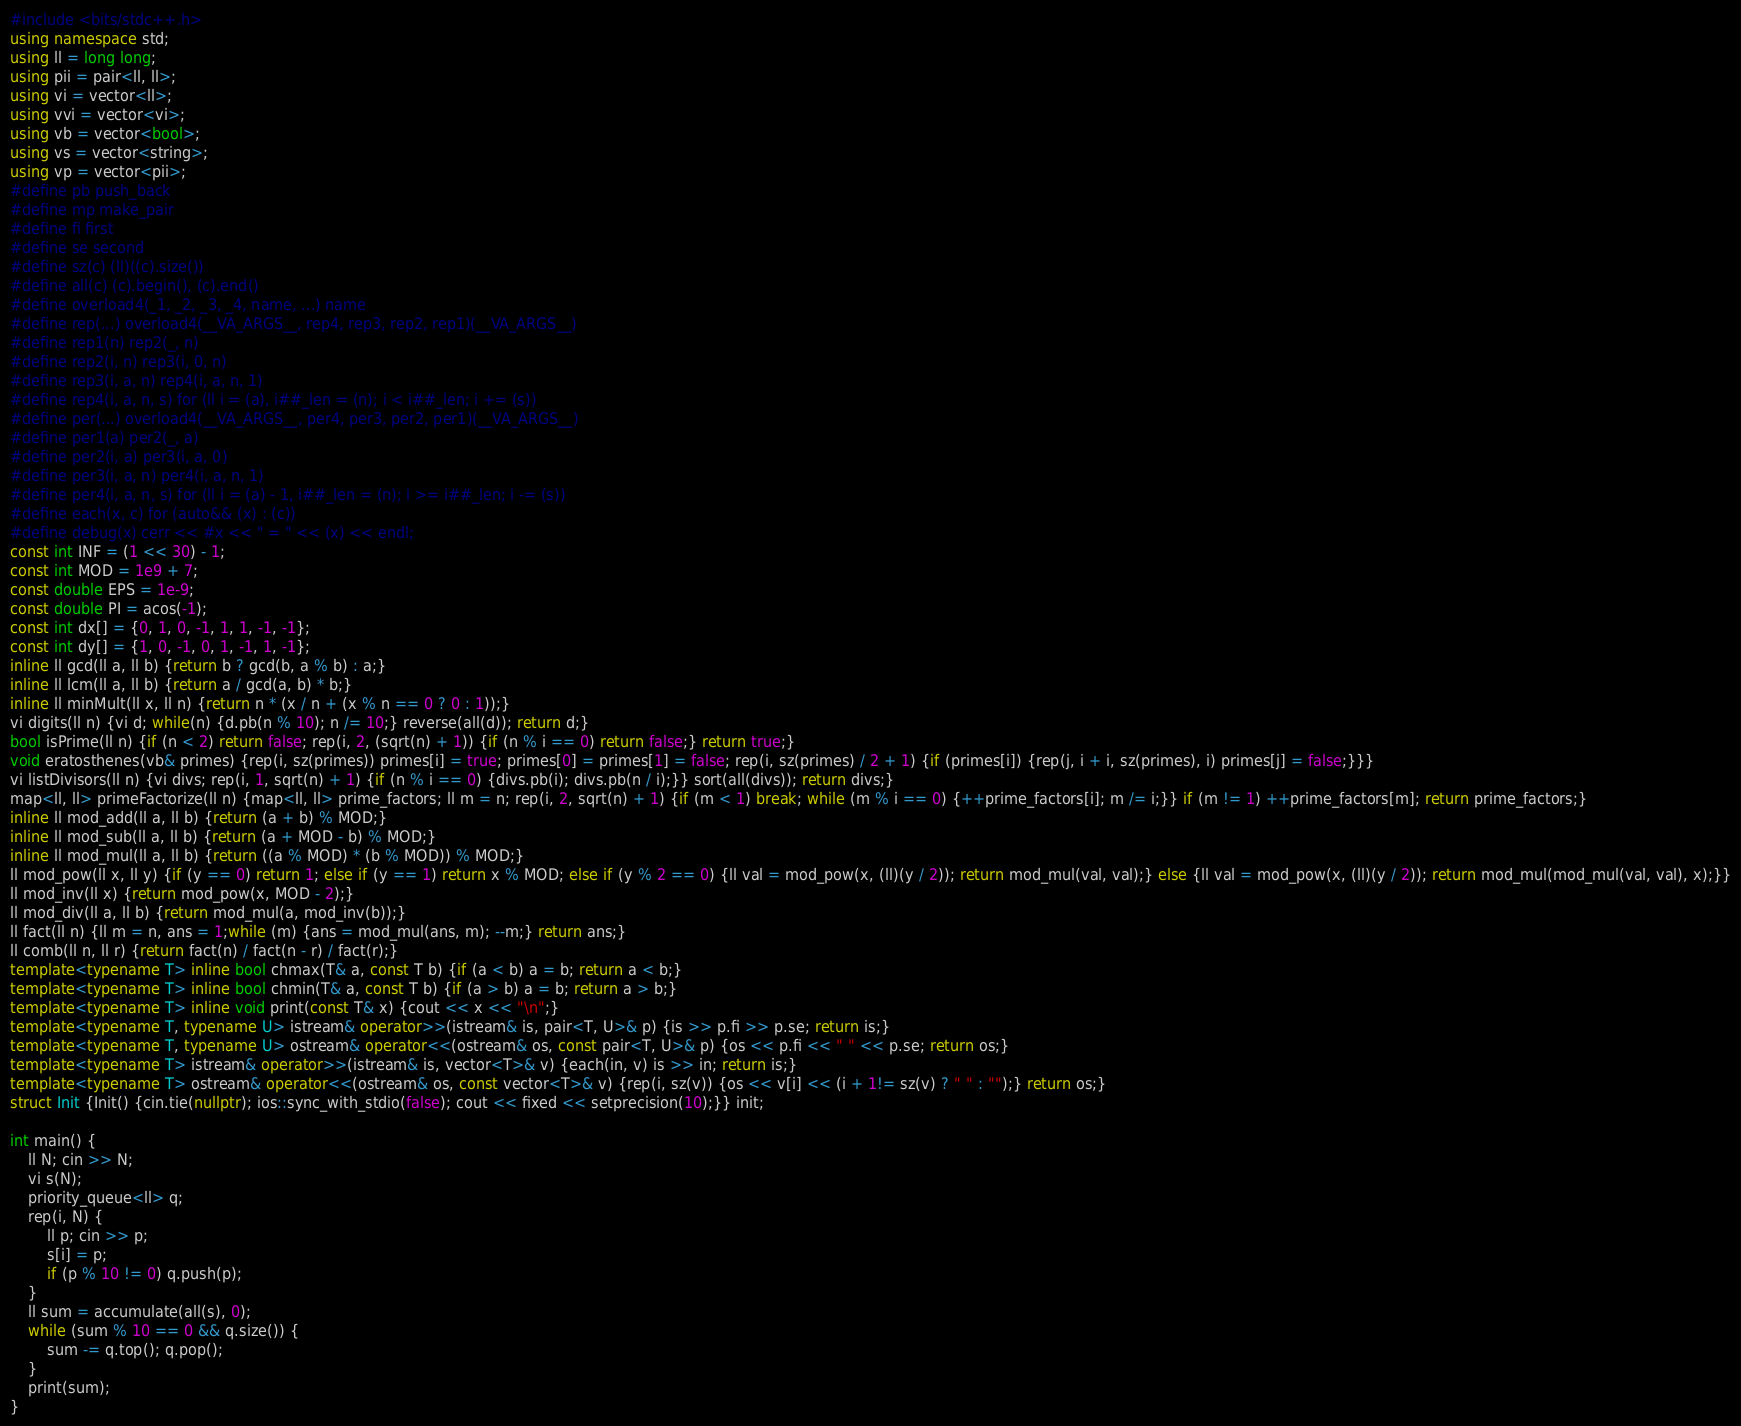<code> <loc_0><loc_0><loc_500><loc_500><_C++_>#include <bits/stdc++.h>
using namespace std;
using ll = long long;
using pii = pair<ll, ll>;
using vi = vector<ll>;
using vvi = vector<vi>;
using vb = vector<bool>;
using vs = vector<string>;
using vp = vector<pii>;
#define pb push_back
#define mp make_pair
#define fi first
#define se second
#define sz(c) (ll)((c).size())
#define all(c) (c).begin(), (c).end()
#define overload4(_1, _2, _3, _4, name, ...) name
#define rep(...) overload4(__VA_ARGS__, rep4, rep3, rep2, rep1)(__VA_ARGS__)
#define rep1(n) rep2(_, n)
#define rep2(i, n) rep3(i, 0, n)
#define rep3(i, a, n) rep4(i, a, n, 1)
#define rep4(i, a, n, s) for (ll i = (a), i##_len = (n); i < i##_len; i += (s))
#define per(...) overload4(__VA_ARGS__, per4, per3, per2, per1)(__VA_ARGS__)
#define per1(a) per2(_, a)
#define per2(i, a) per3(i, a, 0)
#define per3(i, a, n) per4(i, a, n, 1)
#define per4(i, a, n, s) for (ll i = (a) - 1, i##_len = (n); i >= i##_len; i -= (s))
#define each(x, c) for (auto&& (x) : (c))
#define debug(x) cerr << #x << " = " << (x) << endl;
const int INF = (1 << 30) - 1;
const int MOD = 1e9 + 7;
const double EPS = 1e-9;
const double PI = acos(-1);
const int dx[] = {0, 1, 0, -1, 1, 1, -1, -1};
const int dy[] = {1, 0, -1, 0, 1, -1, 1, -1};
inline ll gcd(ll a, ll b) {return b ? gcd(b, a % b) : a;}
inline ll lcm(ll a, ll b) {return a / gcd(a, b) * b;}
inline ll minMult(ll x, ll n) {return n * (x / n + (x % n == 0 ? 0 : 1));}
vi digits(ll n) {vi d; while(n) {d.pb(n % 10); n /= 10;} reverse(all(d)); return d;}
bool isPrime(ll n) {if (n < 2) return false; rep(i, 2, (sqrt(n) + 1)) {if (n % i == 0) return false;} return true;}
void eratosthenes(vb& primes) {rep(i, sz(primes)) primes[i] = true; primes[0] = primes[1] = false; rep(i, sz(primes) / 2 + 1) {if (primes[i]) {rep(j, i + i, sz(primes), i) primes[j] = false;}}}
vi listDivisors(ll n) {vi divs; rep(i, 1, sqrt(n) + 1) {if (n % i == 0) {divs.pb(i); divs.pb(n / i);}} sort(all(divs)); return divs;}
map<ll, ll> primeFactorize(ll n) {map<ll, ll> prime_factors; ll m = n; rep(i, 2, sqrt(n) + 1) {if (m < 1) break; while (m % i == 0) {++prime_factors[i]; m /= i;}} if (m != 1) ++prime_factors[m]; return prime_factors;}
inline ll mod_add(ll a, ll b) {return (a + b) % MOD;}
inline ll mod_sub(ll a, ll b) {return (a + MOD - b) % MOD;}
inline ll mod_mul(ll a, ll b) {return ((a % MOD) * (b % MOD)) % MOD;}
ll mod_pow(ll x, ll y) {if (y == 0) return 1; else if (y == 1) return x % MOD; else if (y % 2 == 0) {ll val = mod_pow(x, (ll)(y / 2)); return mod_mul(val, val);} else {ll val = mod_pow(x, (ll)(y / 2)); return mod_mul(mod_mul(val, val), x);}}
ll mod_inv(ll x) {return mod_pow(x, MOD - 2);}
ll mod_div(ll a, ll b) {return mod_mul(a, mod_inv(b));}
ll fact(ll n) {ll m = n, ans = 1;while (m) {ans = mod_mul(ans, m); --m;} return ans;}
ll comb(ll n, ll r) {return fact(n) / fact(n - r) / fact(r);}
template<typename T> inline bool chmax(T& a, const T b) {if (a < b) a = b; return a < b;}
template<typename T> inline bool chmin(T& a, const T b) {if (a > b) a = b; return a > b;}
template<typename T> inline void print(const T& x) {cout << x << "\n";}
template<typename T, typename U> istream& operator>>(istream& is, pair<T, U>& p) {is >> p.fi >> p.se; return is;}
template<typename T, typename U> ostream& operator<<(ostream& os, const pair<T, U>& p) {os << p.fi << " " << p.se; return os;}
template<typename T> istream& operator>>(istream& is, vector<T>& v) {each(in, v) is >> in; return is;}
template<typename T> ostream& operator<<(ostream& os, const vector<T>& v) {rep(i, sz(v)) {os << v[i] << (i + 1!= sz(v) ? " " : "");} return os;}
struct Init {Init() {cin.tie(nullptr); ios::sync_with_stdio(false); cout << fixed << setprecision(10);}} init;

int main() {
    ll N; cin >> N;
    vi s(N);
    priority_queue<ll> q;
    rep(i, N) {
        ll p; cin >> p;
        s[i] = p;
        if (p % 10 != 0) q.push(p);
    }
    ll sum = accumulate(all(s), 0);
    while (sum % 10 == 0 && q.size()) {
        sum -= q.top(); q.pop();
    }
    print(sum);
}</code> 